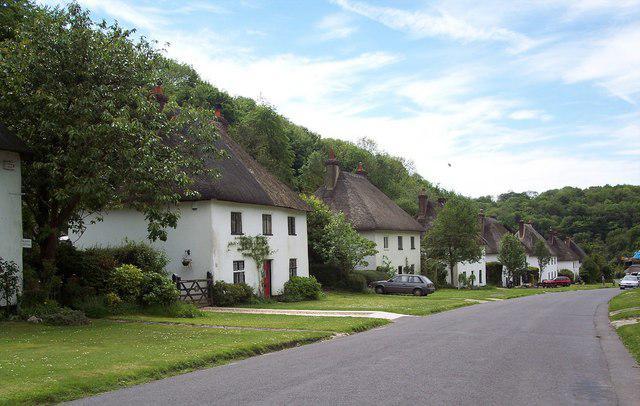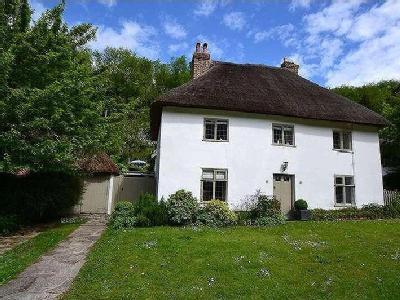The first image is the image on the left, the second image is the image on the right. Analyze the images presented: Is the assertion "A street passes near a row of houses in the image on the left." valid? Answer yes or no. Yes. The first image is the image on the left, the second image is the image on the right. Analyze the images presented: Is the assertion "One image shows a row of at least four rectangular white buildings with dark gray roofs to the left of a paved road, and the other image shows one rectangular white building with a dark gray roof." valid? Answer yes or no. Yes. 